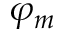<formula> <loc_0><loc_0><loc_500><loc_500>\varphi _ { m }</formula> 